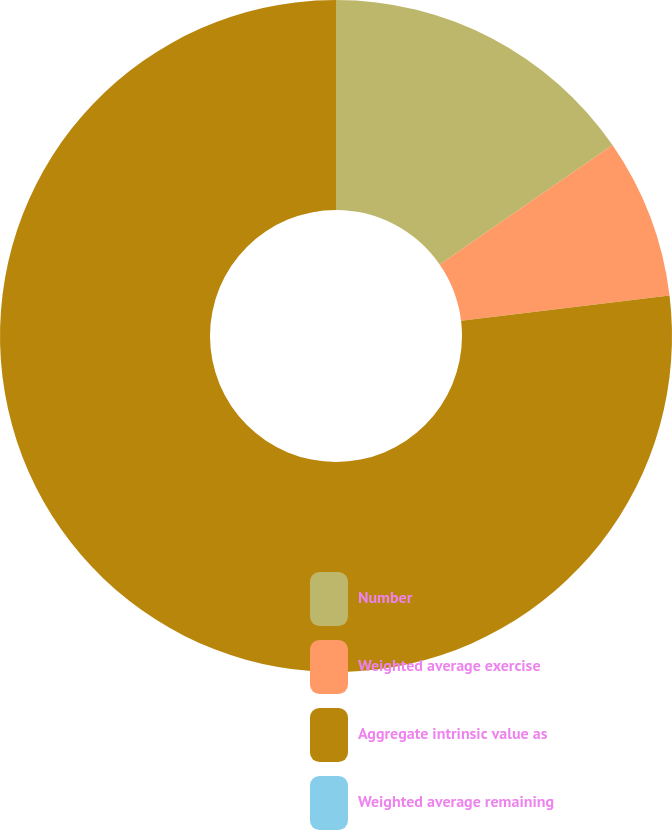<chart> <loc_0><loc_0><loc_500><loc_500><pie_chart><fcel>Number<fcel>Weighted average exercise<fcel>Aggregate intrinsic value as<fcel>Weighted average remaining<nl><fcel>15.38%<fcel>7.69%<fcel>76.92%<fcel>0.0%<nl></chart> 